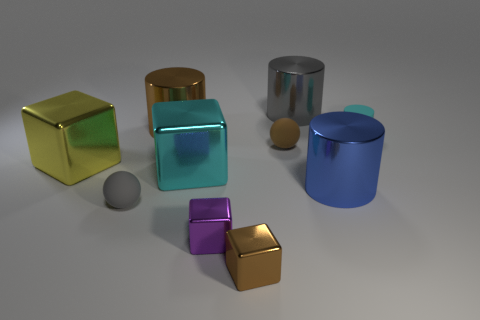Are the gray object in front of the cyan matte cylinder and the big gray thing made of the same material?
Provide a succinct answer. No. Are there fewer large brown shiny things on the right side of the tiny cyan cylinder than cyan metal blocks?
Make the answer very short. Yes. What number of metallic objects are big cyan spheres or cubes?
Offer a terse response. 4. Is there anything else that has the same color as the tiny cylinder?
Provide a short and direct response. Yes. Do the brown metal object that is behind the blue thing and the gray thing that is behind the gray rubber sphere have the same shape?
Keep it short and to the point. Yes. How many things are small cyan rubber objects or cylinders that are to the left of the purple metal object?
Your response must be concise. 2. How many other objects are the same size as the yellow thing?
Ensure brevity in your answer.  4. Are the brown thing behind the tiny matte cylinder and the object on the left side of the small gray rubber object made of the same material?
Your response must be concise. Yes. There is a small purple shiny cube; what number of gray rubber balls are in front of it?
Provide a succinct answer. 0. What number of red things are either large shiny objects or matte cylinders?
Make the answer very short. 0. 